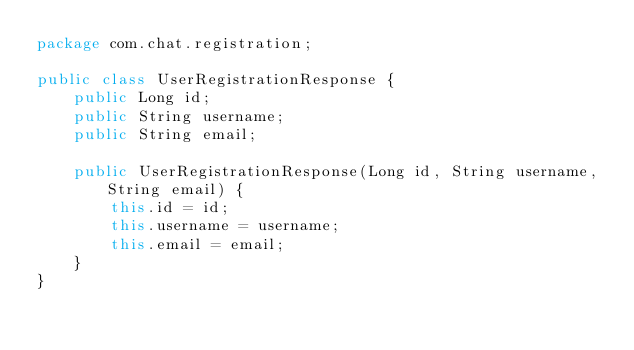Convert code to text. <code><loc_0><loc_0><loc_500><loc_500><_Java_>package com.chat.registration;

public class UserRegistrationResponse {
    public Long id;
    public String username;
    public String email;

    public UserRegistrationResponse(Long id, String username, String email) {
        this.id = id;
        this.username = username;
        this.email = email;
    }
}
</code> 